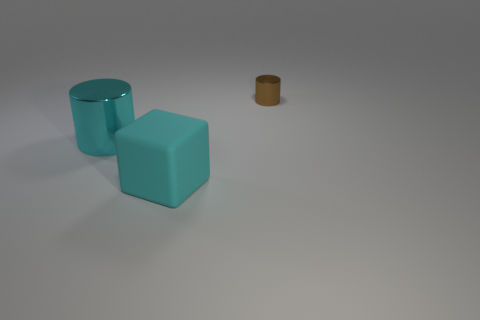Add 1 brown shiny things. How many objects exist? 4 Subtract all cubes. How many objects are left? 2 Subtract all purple cylinders. Subtract all blue cubes. How many cylinders are left? 2 Subtract all cyan rubber objects. Subtract all big matte things. How many objects are left? 1 Add 3 large cyan metallic cylinders. How many large cyan metallic cylinders are left? 4 Add 3 purple rubber balls. How many purple rubber balls exist? 3 Subtract 0 purple blocks. How many objects are left? 3 